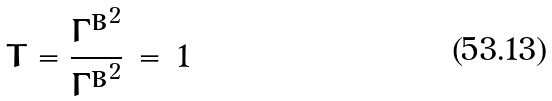Convert formula to latex. <formula><loc_0><loc_0><loc_500><loc_500>T = \frac { { \Gamma ^ { B } } ^ { 2 } } { { \Gamma ^ { B } } ^ { 2 } } \, = \, 1</formula> 